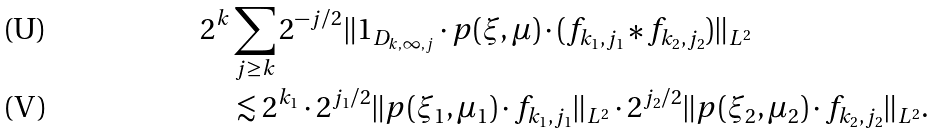<formula> <loc_0><loc_0><loc_500><loc_500>2 ^ { k } & \sum _ { j \geq k } 2 ^ { - j / 2 } \| 1 _ { D _ { k , \infty , j } } \cdot p ( \xi , \mu ) \cdot ( f _ { k _ { 1 } , j _ { 1 } } \ast f _ { k _ { 2 } , j _ { 2 } } ) \| _ { L ^ { 2 } } \\ & \lesssim 2 ^ { k _ { 1 } } \cdot 2 ^ { j _ { 1 } / 2 } \| p ( \xi _ { 1 } , \mu _ { 1 } ) \cdot f _ { k _ { 1 } , j _ { 1 } } \| _ { L ^ { 2 } } \cdot 2 ^ { j _ { 2 } / 2 } \| p ( \xi _ { 2 } , \mu _ { 2 } ) \cdot f _ { k _ { 2 } , j _ { 2 } } \| _ { L ^ { 2 } } .</formula> 